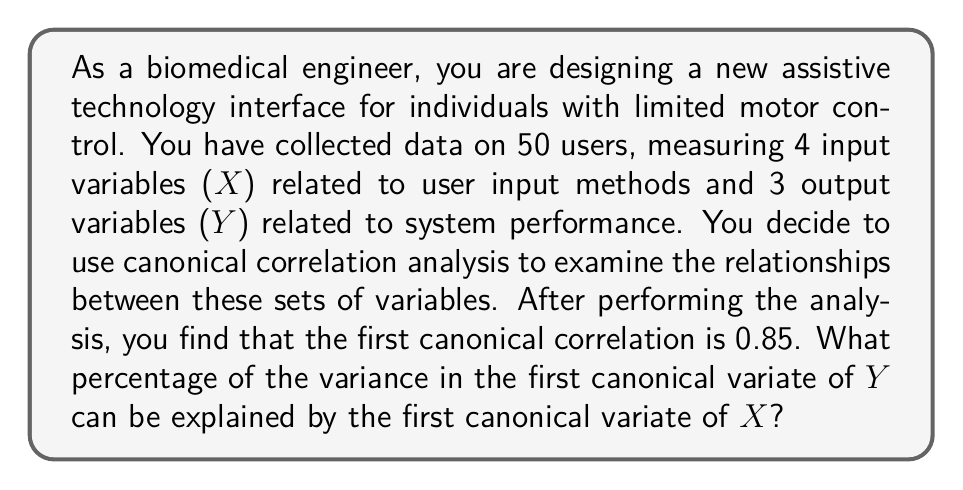Provide a solution to this math problem. To solve this problem, we need to understand the relationship between canonical correlation and explained variance. The steps to arrive at the solution are as follows:

1) In canonical correlation analysis, we find linear combinations of X and Y variables that maximize the correlation between them. These linear combinations are called canonical variates.

2) The canonical correlation coefficient (r) represents the correlation between the canonical variates of X and Y.

3) The square of the canonical correlation coefficient (r²) represents the proportion of variance shared between the canonical variates.

4) In this case, we are given that the first canonical correlation is 0.85.

5) To find the percentage of variance in the first canonical variate of Y explained by the first canonical variate of X, we need to calculate r²:

   $$r^2 = (0.85)^2 = 0.7225$$

6) To express this as a percentage, we multiply by 100:

   $$0.7225 \times 100 = 72.25\%$$

Therefore, 72.25% of the variance in the first canonical variate of Y can be explained by the first canonical variate of X.
Answer: 72.25% 